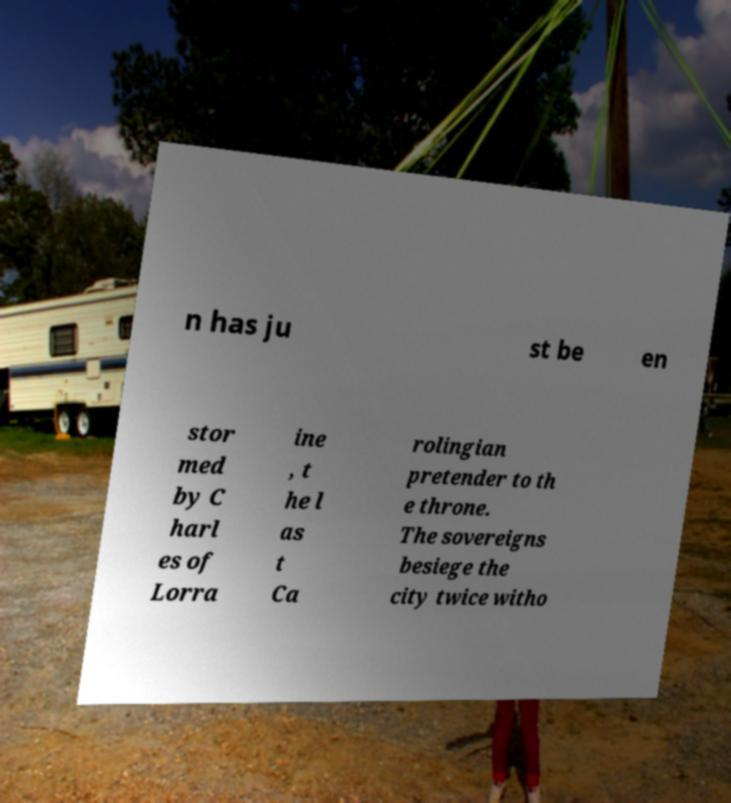I need the written content from this picture converted into text. Can you do that? n has ju st be en stor med by C harl es of Lorra ine , t he l as t Ca rolingian pretender to th e throne. The sovereigns besiege the city twice witho 